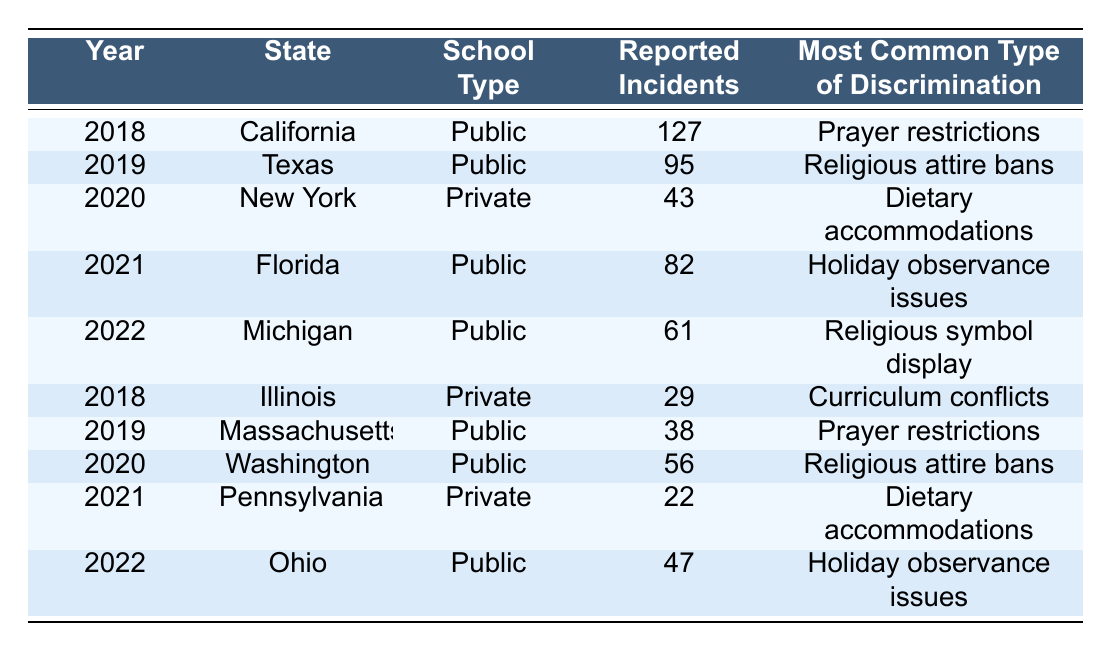What year had the highest number of reported incidents? In the table, the reported incidents are listed by year. By comparing the values, California in 2018 has the highest number with 127 incidents.
Answer: 2018 Which school type reported the fewest incidents? By scanning through the "Reported Incidents" column for private schools, Illinois in 2018 reported the fewest incidents, with only 29.
Answer: Private What is the common type of discrimination reported in Texas schools? Looking at the row for Texas in 2019, it shows that the most common type of discrimination reported was religious attire bans.
Answer: Religious attire bans How many total reported incidents were recorded in Florida between 2021 and 2022? Adding the reported incidents from Florida in 2021 (82) and 2022 (not listed in Florida, so only 82 is counted). The total for Florida is 82.
Answer: 82 Did New York report any incidents related to prayer restrictions? In the table, New York's entry for 2020 lists dietary accommodations as the most common discrimination type, indicating that there were no reported incidents related to prayer restrictions.
Answer: No What was the average number of reported incidents for public schools over the years listed? To find the average, sum the reported incidents for public schools: 127 (2018) + 95 (2019) + 82 (2021) + 61 (2022) + 38 (2019) + 56 (2020) + 47 (2022) = 506. Then divide by the number of years reported (7), which results in an average of 506/7 = 72.29.
Answer: 72.29 Which state had the most unique types of discrimination reported? Review the “Most Common Type of Discrimination” for each state listed; California, Texas, New York, Florida, Michigan, Illinois, Massachusetts, Washington, Pennsylvania, and Ohio each had their unique reported types. Each state differed, indicating a diverse range that totals 10 unique types.
Answer: 10 In how many cases were dietary accommodations the most common type of discrimination? The table shows that there are two instances (2020 in New York and 2021 in Pennsylvania) where dietary accommodations were noted as the most common type of discrimination.
Answer: 2 